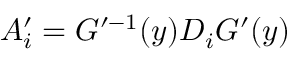Convert formula to latex. <formula><loc_0><loc_0><loc_500><loc_500>A _ { i } ^ { \prime } = G ^ { \prime - 1 } ( y ) D _ { i } G ^ { \prime } ( y )</formula> 